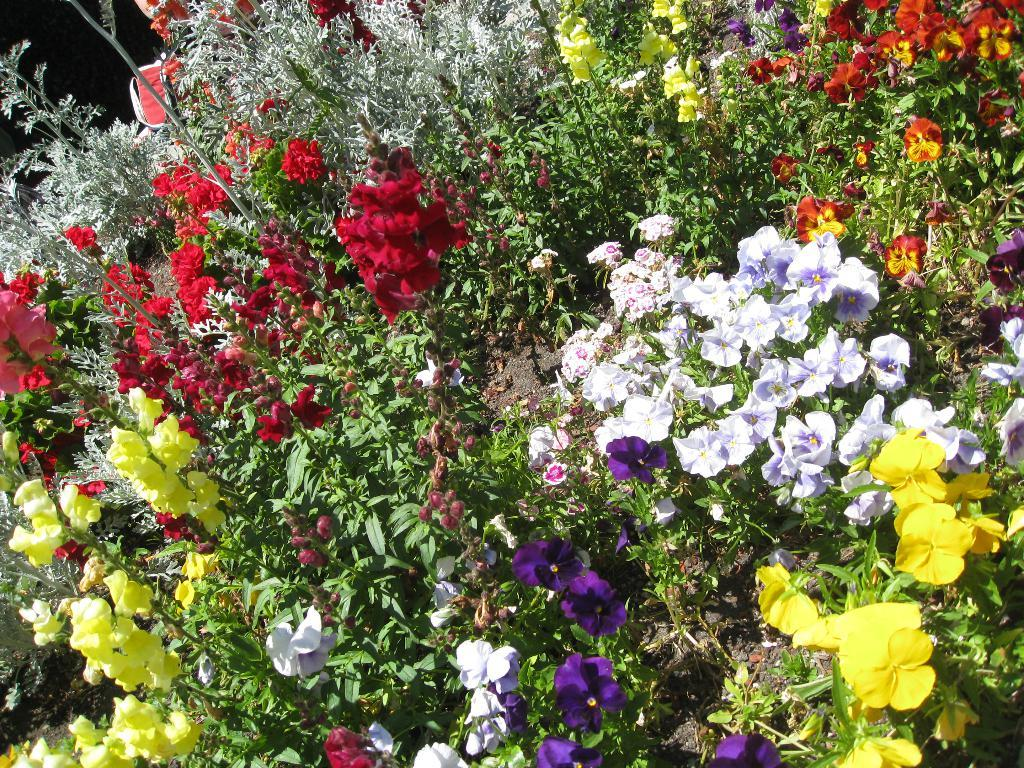What type of plants can be seen in the image? There are colorful flowers in the image. Can you describe the appearance of the flowers? The flowers have various colors, which makes them visually appealing. Who is the manager of the window in the image? There is no window or manager present in the image; it only features colorful flowers. 